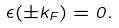<formula> <loc_0><loc_0><loc_500><loc_500>\epsilon ( \pm k _ { F } ) = 0 .</formula> 